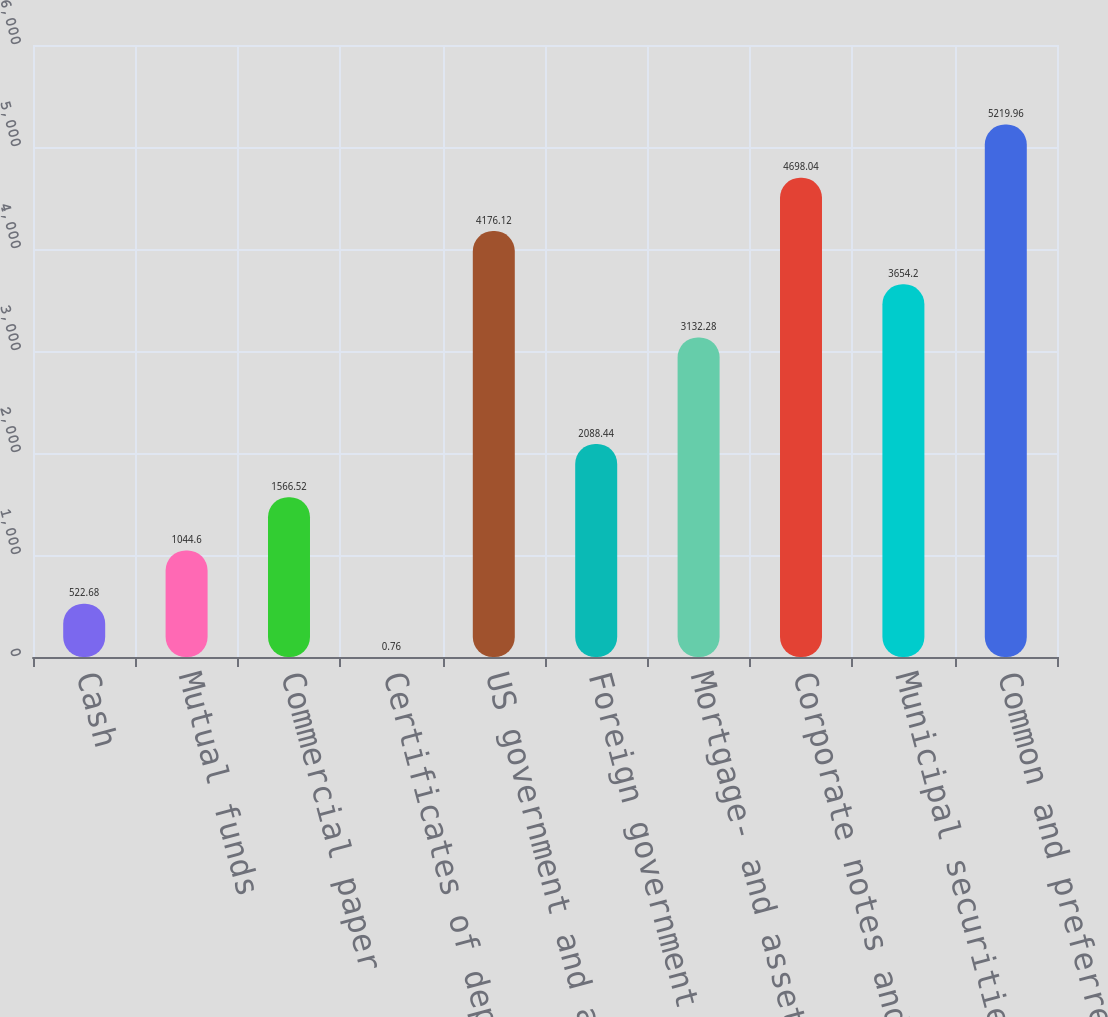Convert chart to OTSL. <chart><loc_0><loc_0><loc_500><loc_500><bar_chart><fcel>Cash<fcel>Mutual funds<fcel>Commercial paper<fcel>Certificates of deposit<fcel>US government and agency<fcel>Foreign government bonds<fcel>Mortgage- and asset-backed<fcel>Corporate notes and bonds<fcel>Municipal securities<fcel>Common and preferred stock<nl><fcel>522.68<fcel>1044.6<fcel>1566.52<fcel>0.76<fcel>4176.12<fcel>2088.44<fcel>3132.28<fcel>4698.04<fcel>3654.2<fcel>5219.96<nl></chart> 